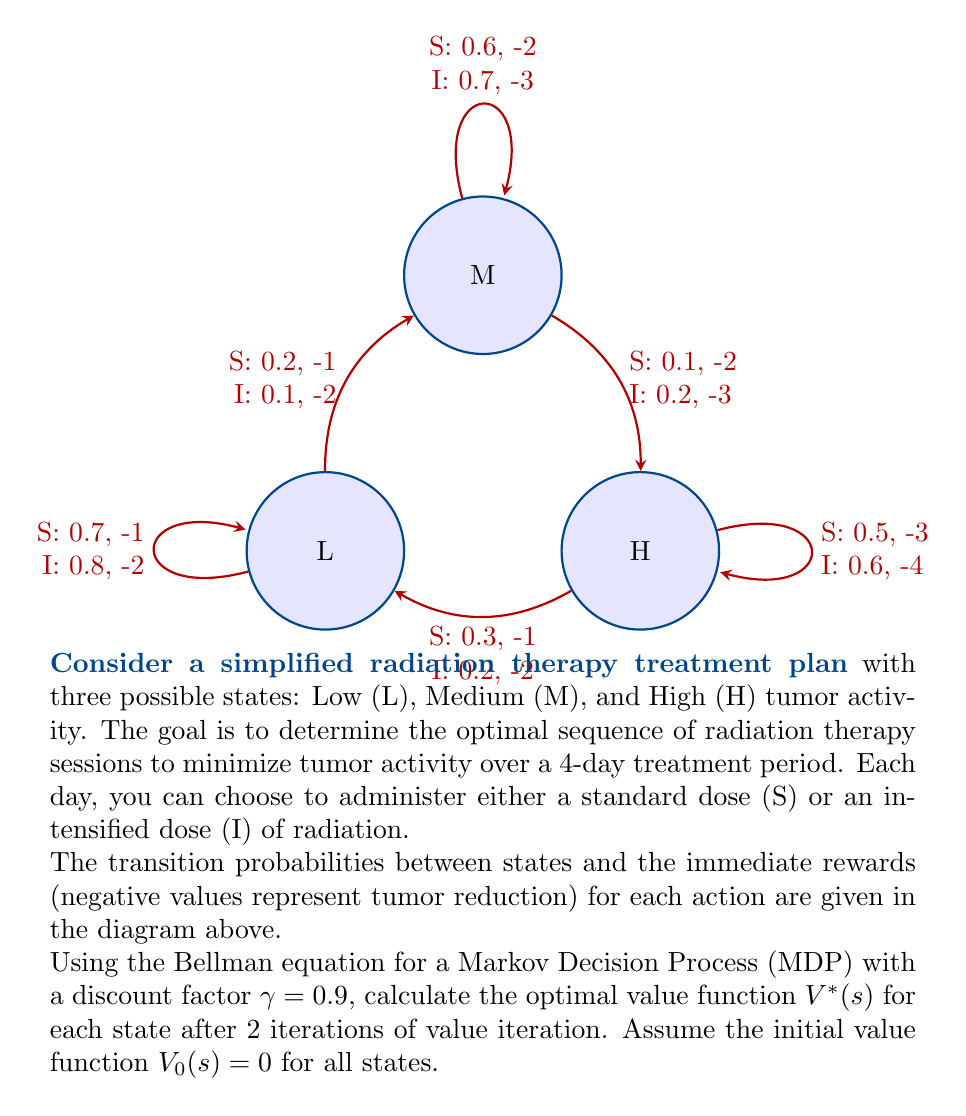Show me your answer to this math problem. To solve this problem, we'll use the Bellman optimality equation for the value function:

$$V^*(s) = \max_a \left(R(s,a) + \gamma \sum_{s'} P(s'|s,a) V^*(s')\right)$$

Where:
- $V^*(s)$ is the optimal value function for state $s$
- $R(s,a)$ is the immediate reward for taking action $a$ in state $s$
- $P(s'|s,a)$ is the transition probability from state $s$ to $s'$ when taking action $a$
- $\gamma = 0.9$ is the discount factor

We'll perform 2 iterations of value iteration:

Iteration 1:
For each state, we calculate the value for both actions (S and I) and take the maximum.

For state L:
$V_1(L) = \max \begin{cases}
-1 + 0.9(0.7 \cdot 0 + 0.2 \cdot 0 + 0.1 \cdot 0) = -1 \quad \text{(S)}\\
-2 + 0.9(0.8 \cdot 0 + 0.1 \cdot 0 + 0.1 \cdot 0) = -2 \quad \text{(I)}
\end{cases} = -1$

For state M:
$V_1(M) = \max \begin{cases}
-2 + 0.9(0.2 \cdot 0 + 0.6 \cdot 0 + 0.2 \cdot 0) = -2 \quad \text{(S)}\\
-3 + 0.9(0.1 \cdot 0 + 0.7 \cdot 0 + 0.2 \cdot 0) = -3 \quad \text{(I)}
\end{cases} = -2$

For state H:
$V_1(H) = \max \begin{cases}
-3 + 0.9(0.3 \cdot 0 + 0.2 \cdot 0 + 0.5 \cdot 0) = -3 \quad \text{(S)}\\
-4 + 0.9(0.2 \cdot 0 + 0.2 \cdot 0 + 0.6 \cdot 0) = -4 \quad \text{(I)}
\end{cases} = -3$

Iteration 2:
We use the values from iteration 1 to calculate the new values.

For state L:
$V_2(L) = \max \begin{cases}
-1 + 0.9(0.7 \cdot -1 + 0.2 \cdot -2 + 0.1 \cdot -3) = -2.53 \quad \text{(S)}\\
-2 + 0.9(0.8 \cdot -1 + 0.1 \cdot -2 + 0.1 \cdot -3) = -3.17 \quad \text{(I)}
\end{cases} = -2.53$

For state M:
$V_2(M) = \max \begin{cases}
-2 + 0.9(0.2 \cdot -1 + 0.6 \cdot -2 + 0.2 \cdot -3) = -3.62 \quad \text{(S)}\\
-3 + 0.9(0.1 \cdot -1 + 0.7 \cdot -2 + 0.2 \cdot -3) = -4.59 \quad \text{(I)}
\end{cases} = -3.62$

For state H:
$V_2(H) = \max \begin{cases}
-3 + 0.9(0.3 \cdot -1 + 0.2 \cdot -2 + 0.5 \cdot -3) = -4.71 \quad \text{(S)}\\
-4 + 0.9(0.2 \cdot -1 + 0.2 \cdot -2 + 0.6 \cdot -3) = -5.58 \quad \text{(I)}
\end{cases} = -4.71$

Therefore, after 2 iterations, the optimal value function for each state is:
$V^*(L) = -2.53$
$V^*(M) = -3.62$
$V^*(H) = -4.71$
Answer: $V^*(L) = -2.53, V^*(M) = -3.62, V^*(H) = -4.71$ 